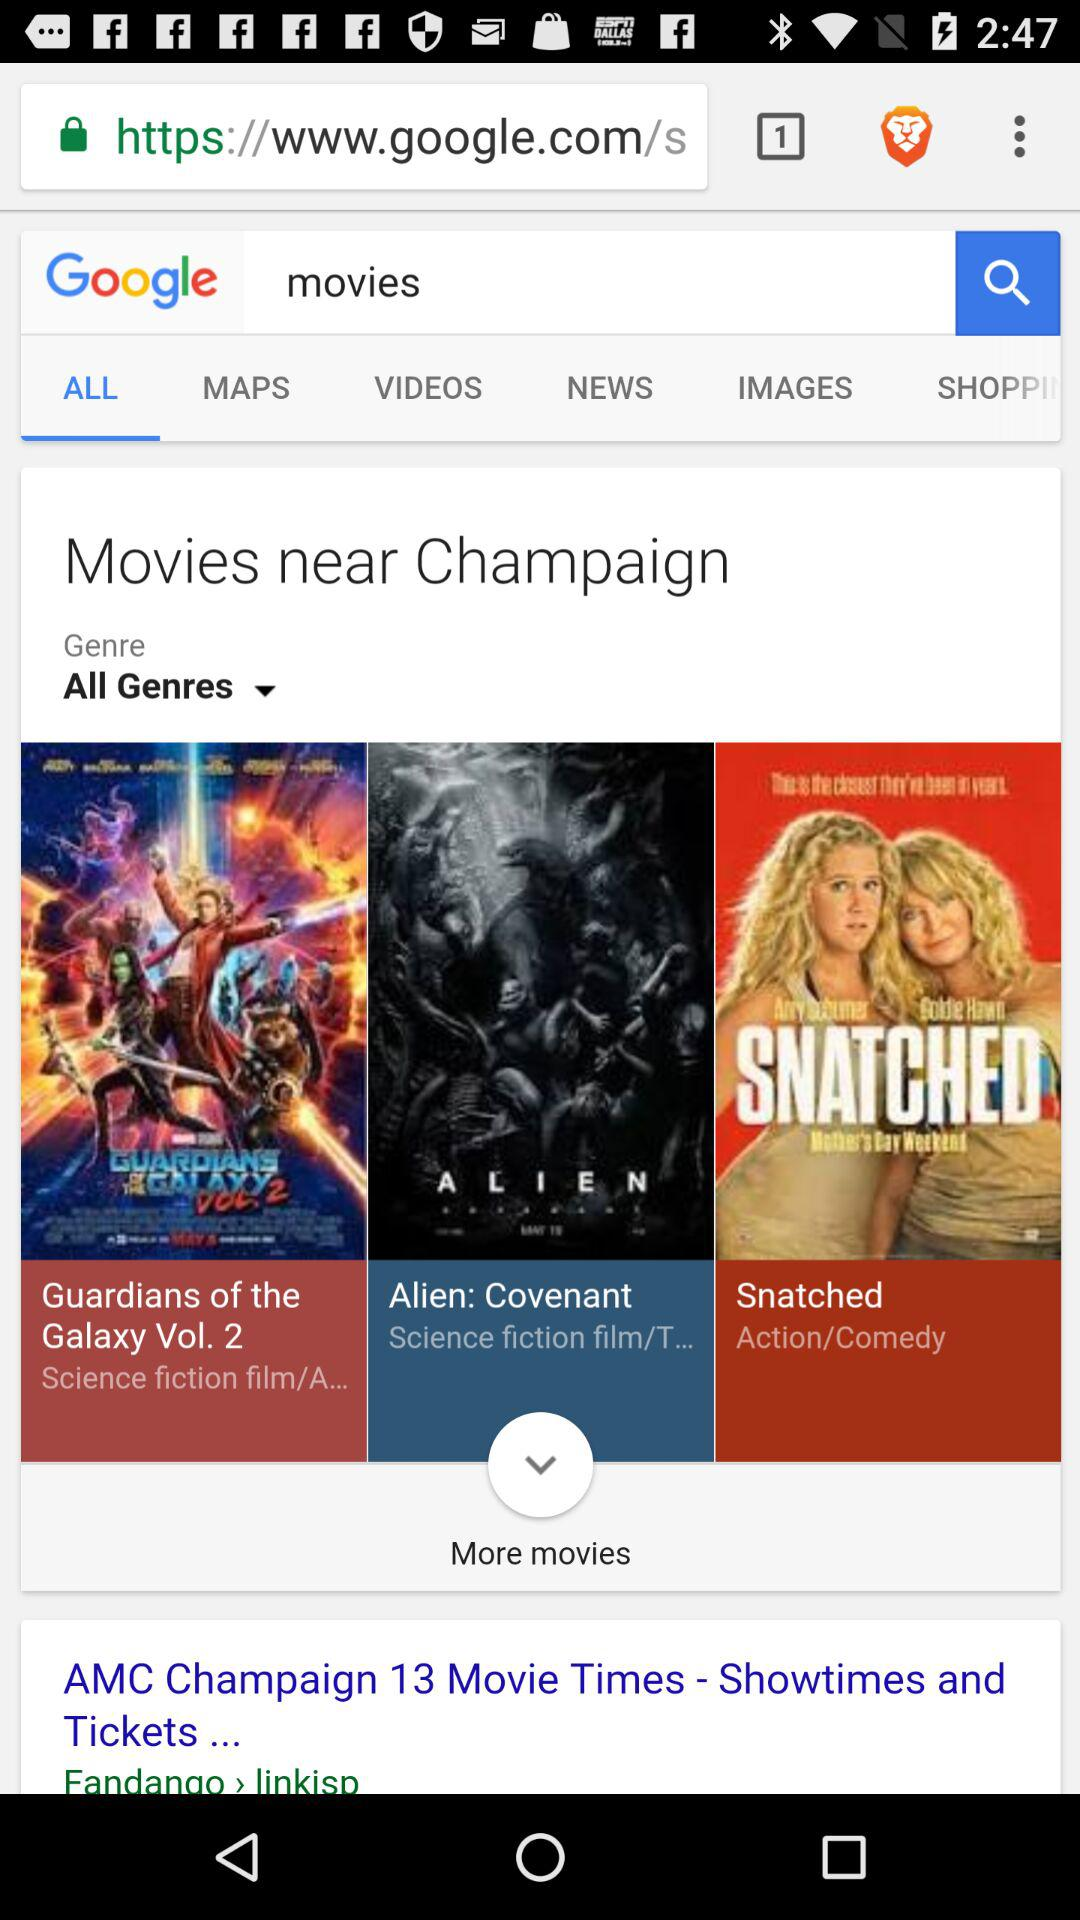What is selected in a genre? The selected genres is "All Genres". 